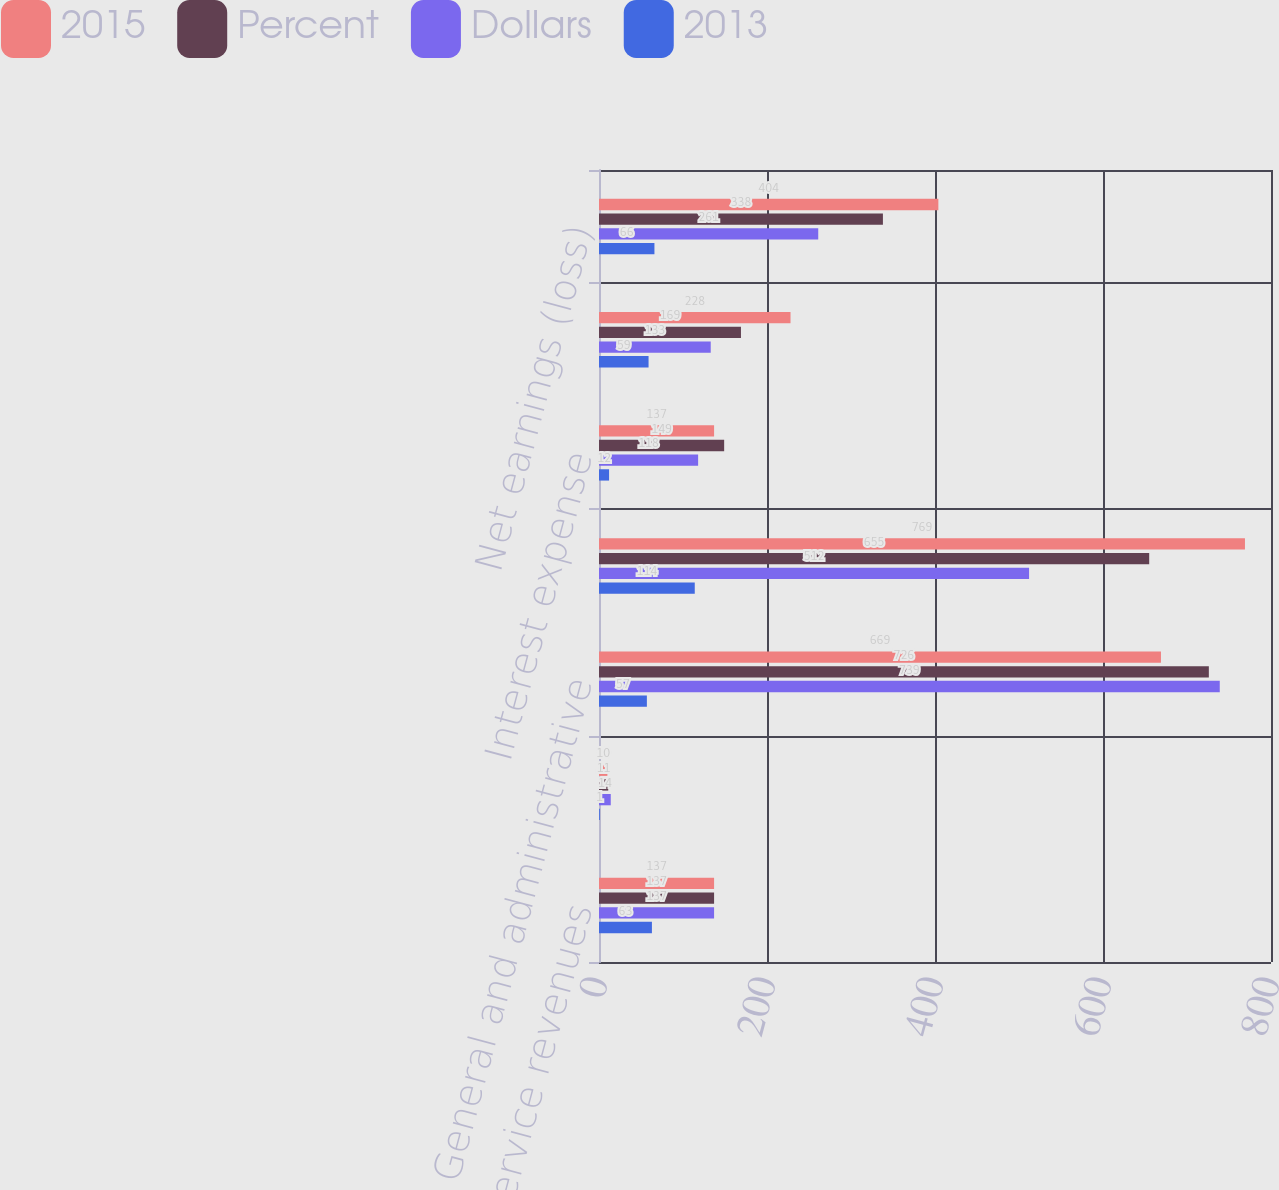Convert chart. <chart><loc_0><loc_0><loc_500><loc_500><stacked_bar_chart><ecel><fcel>Sales and service revenues<fcel>Income (loss) from operating<fcel>General and administrative<fcel>Operating income (loss)<fcel>Interest expense<fcel>Federal and foreign income<fcel>Net earnings (loss)<nl><fcel>2015<fcel>137<fcel>10<fcel>669<fcel>769<fcel>137<fcel>228<fcel>404<nl><fcel>Percent<fcel>137<fcel>11<fcel>726<fcel>655<fcel>149<fcel>169<fcel>338<nl><fcel>Dollars<fcel>137<fcel>14<fcel>739<fcel>512<fcel>118<fcel>133<fcel>261<nl><fcel>2013<fcel>63<fcel>1<fcel>57<fcel>114<fcel>12<fcel>59<fcel>66<nl></chart> 